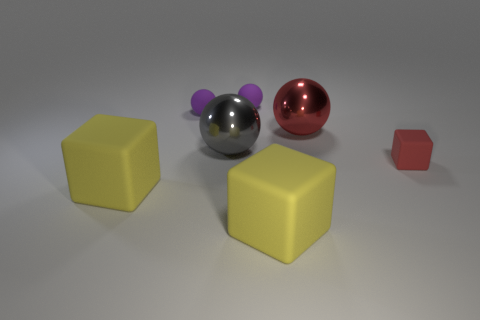Add 1 small rubber blocks. How many objects exist? 8 Subtract all blocks. How many objects are left? 4 Subtract 0 blue cubes. How many objects are left? 7 Subtract all tiny red blocks. Subtract all small objects. How many objects are left? 3 Add 6 tiny purple objects. How many tiny purple objects are left? 8 Add 4 big red cylinders. How many big red cylinders exist? 4 